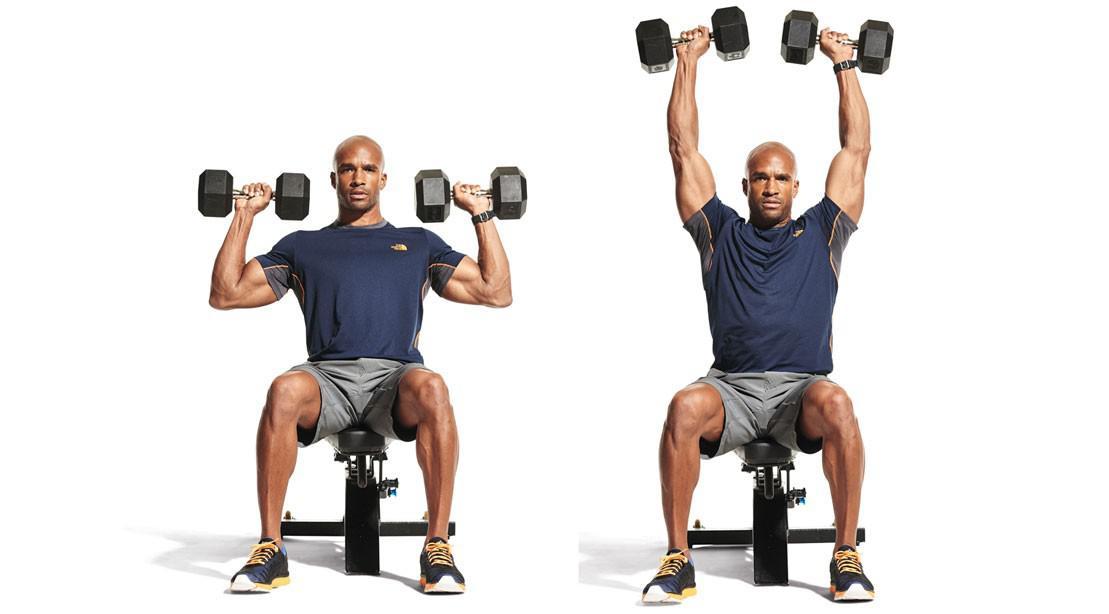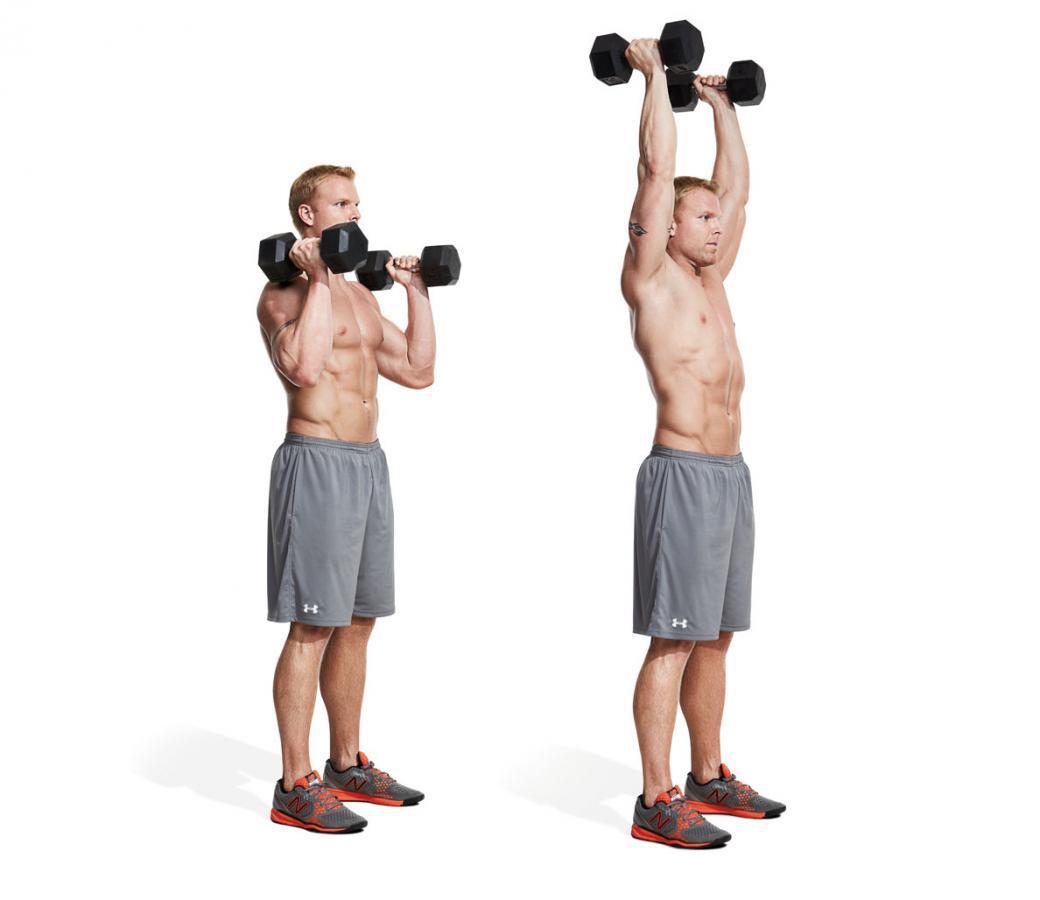The first image is the image on the left, the second image is the image on the right. Considering the images on both sides, is "The left image shows a female working out." valid? Answer yes or no. No. The first image is the image on the left, the second image is the image on the right. Evaluate the accuracy of this statement regarding the images: "One image shows a woman doing weightlifting exercises". Is it true? Answer yes or no. No. 